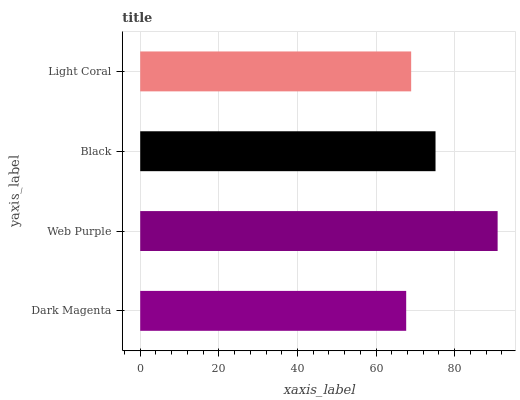Is Dark Magenta the minimum?
Answer yes or no. Yes. Is Web Purple the maximum?
Answer yes or no. Yes. Is Black the minimum?
Answer yes or no. No. Is Black the maximum?
Answer yes or no. No. Is Web Purple greater than Black?
Answer yes or no. Yes. Is Black less than Web Purple?
Answer yes or no. Yes. Is Black greater than Web Purple?
Answer yes or no. No. Is Web Purple less than Black?
Answer yes or no. No. Is Black the high median?
Answer yes or no. Yes. Is Light Coral the low median?
Answer yes or no. Yes. Is Light Coral the high median?
Answer yes or no. No. Is Dark Magenta the low median?
Answer yes or no. No. 